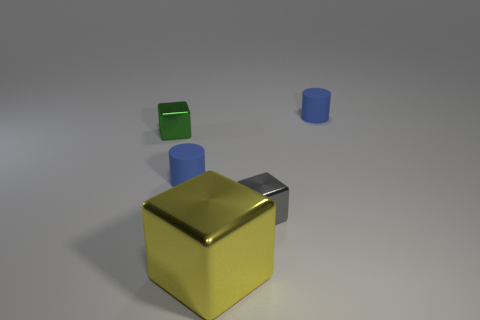Is there anything else that has the same size as the yellow metal cube?
Ensure brevity in your answer.  No. Do the big yellow cube and the green block have the same material?
Keep it short and to the point. Yes. How many blue rubber things are behind the large yellow metallic cube?
Give a very brief answer. 2. What is the tiny thing that is both in front of the green metal cube and to the right of the large yellow block made of?
Your answer should be compact. Metal. How many blue cylinders have the same size as the gray block?
Make the answer very short. 2. There is a tiny rubber cylinder that is on the left side of the small blue cylinder that is on the right side of the large yellow shiny thing; what color is it?
Your response must be concise. Blue. Is there a big yellow cylinder?
Make the answer very short. No. Is the shape of the small green shiny thing the same as the large metallic thing?
Make the answer very short. Yes. There is a cylinder to the left of the large yellow shiny object; how many tiny blue cylinders are right of it?
Offer a very short reply. 1. What number of cubes are both right of the yellow thing and on the left side of the large yellow metal object?
Your response must be concise. 0. 